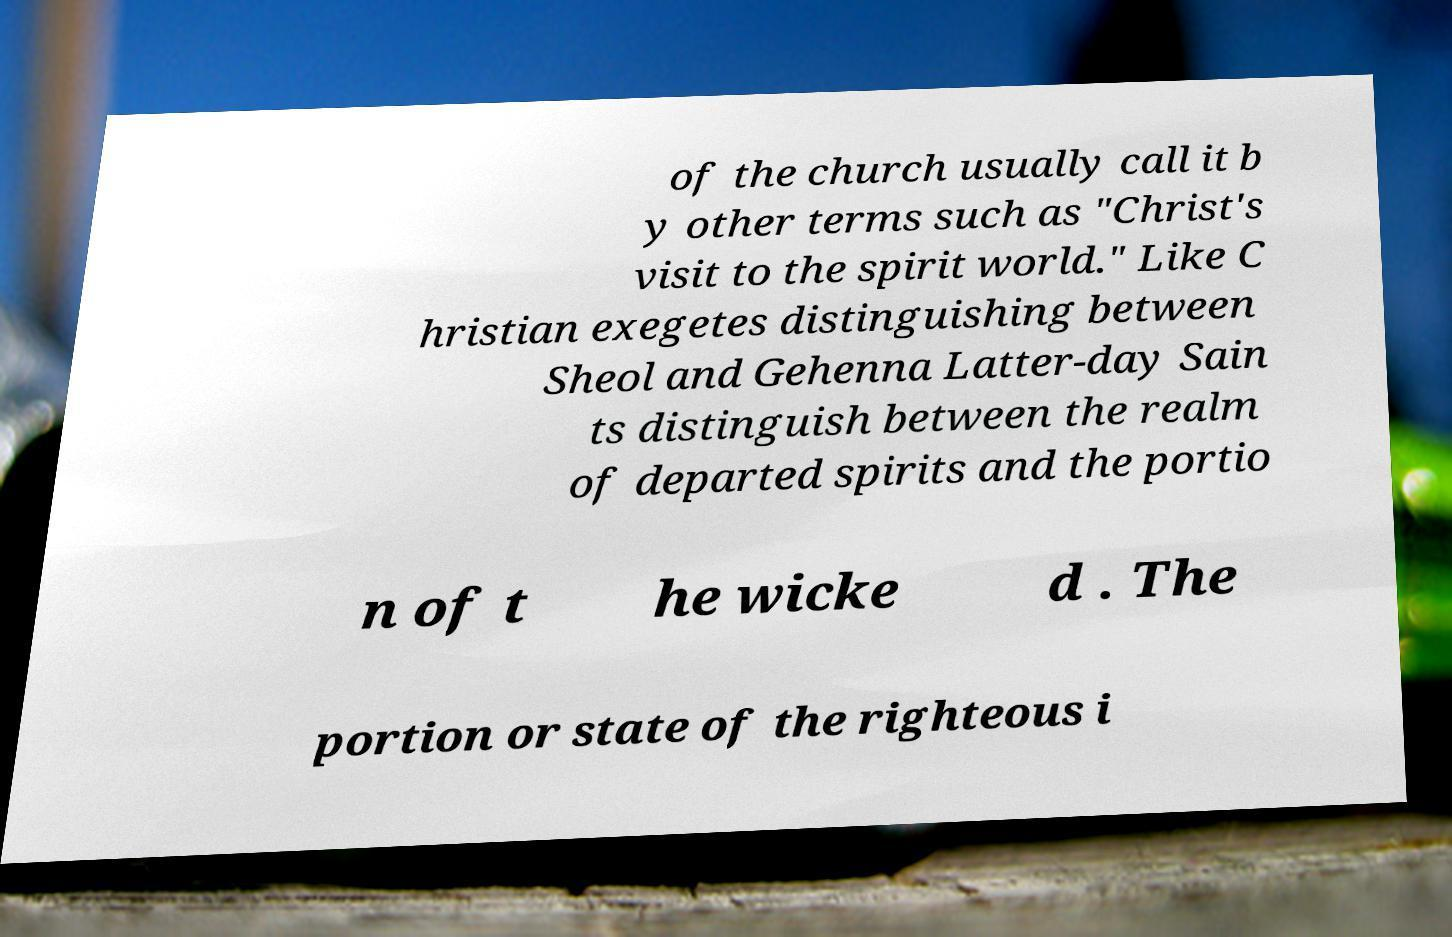Could you extract and type out the text from this image? of the church usually call it b y other terms such as "Christ's visit to the spirit world." Like C hristian exegetes distinguishing between Sheol and Gehenna Latter-day Sain ts distinguish between the realm of departed spirits and the portio n of t he wicke d . The portion or state of the righteous i 